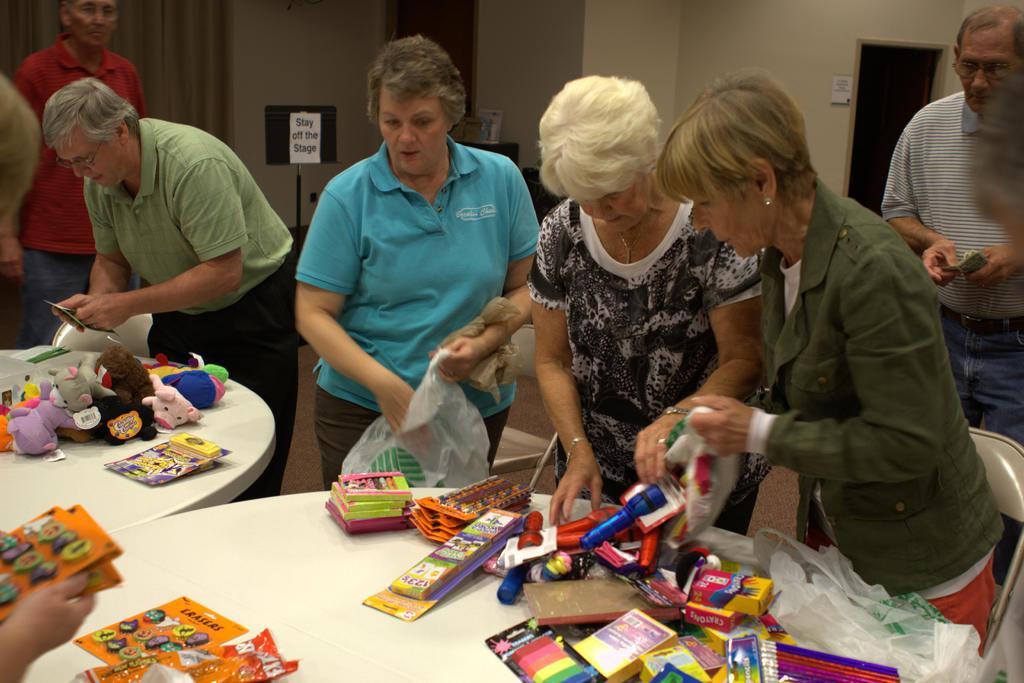In one or two sentences, can you explain what this image depicts? This picture shows few people standing and we see a man holding a mobile in his hand and we see few soft toys and toys on the table and we see a woman holding a carry bag in the hand and we see a man standing on the back. He wore spectacles on his face and we see a poster on the wall and curtains to the window and we see couple of chairs and tables. 